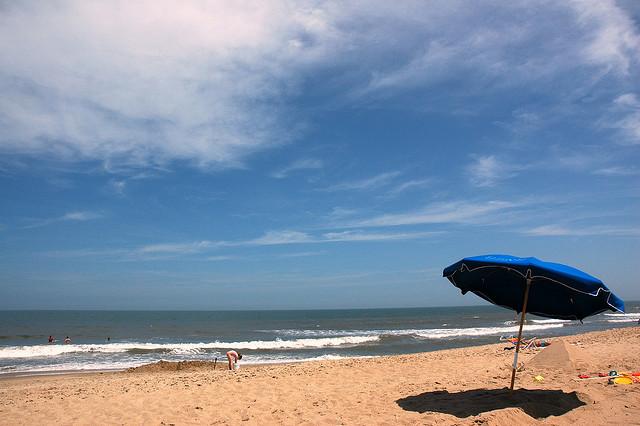Is a shadow cast?
Give a very brief answer. Yes. What color is the umbrella?
Write a very short answer. Blue. Do you see any towels on the beach?
Give a very brief answer. No. 